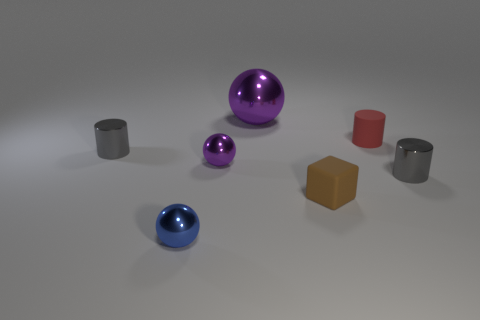How do the different materials in the image compare in terms of their appearance and potential real-world applications? In the image, we have a variety of materials with different appearances. The shiny balls, likely made of a polished metal or plastic, reflect light crisply and could be used for decorative purposes or in objects where visual appeal is important. The matte cylinders absorb more light and have a softer appearance, which might be preferable for items that require minimal glare. The cube has a solid, opaque look and might be used in building blocks or educational toys for children. Each material's appearance suggests different uses based on properties like luster, opacity, and texture. 